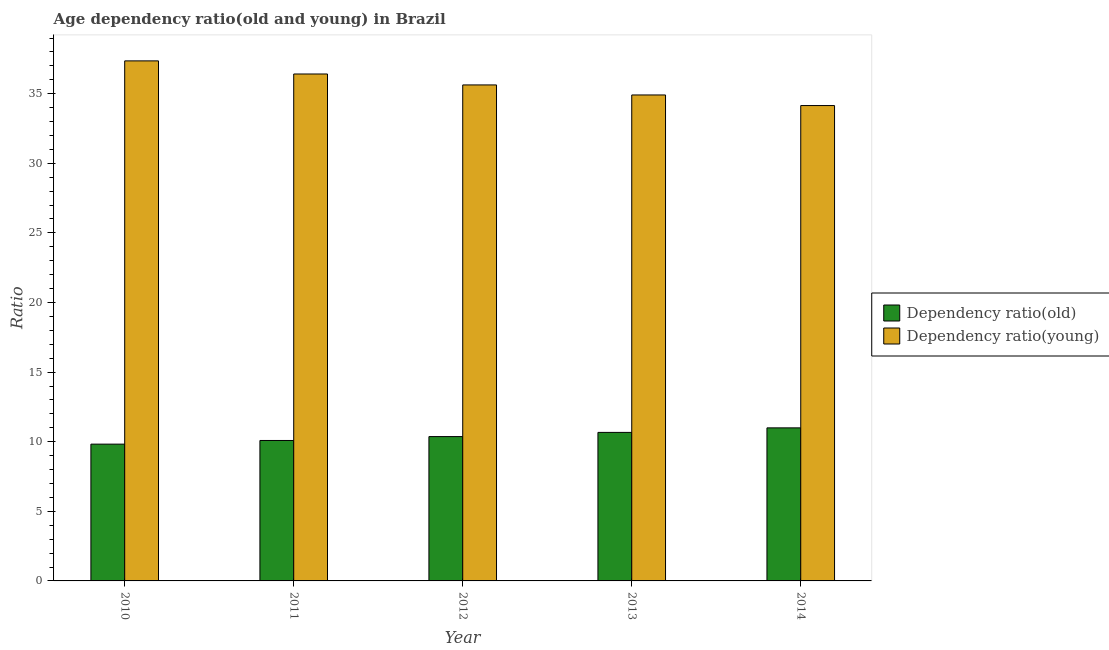How many different coloured bars are there?
Your response must be concise. 2. Are the number of bars per tick equal to the number of legend labels?
Make the answer very short. Yes. Are the number of bars on each tick of the X-axis equal?
Ensure brevity in your answer.  Yes. What is the age dependency ratio(old) in 2013?
Give a very brief answer. 10.67. Across all years, what is the maximum age dependency ratio(old)?
Offer a very short reply. 11. Across all years, what is the minimum age dependency ratio(young)?
Provide a short and direct response. 34.15. What is the total age dependency ratio(old) in the graph?
Offer a terse response. 51.95. What is the difference between the age dependency ratio(old) in 2010 and that in 2011?
Provide a succinct answer. -0.26. What is the difference between the age dependency ratio(old) in 2012 and the age dependency ratio(young) in 2010?
Offer a terse response. 0.54. What is the average age dependency ratio(old) per year?
Your answer should be very brief. 10.39. What is the ratio of the age dependency ratio(young) in 2010 to that in 2013?
Ensure brevity in your answer.  1.07. What is the difference between the highest and the second highest age dependency ratio(young)?
Give a very brief answer. 0.94. What is the difference between the highest and the lowest age dependency ratio(young)?
Your answer should be very brief. 3.21. In how many years, is the age dependency ratio(young) greater than the average age dependency ratio(young) taken over all years?
Your answer should be compact. 2. What does the 2nd bar from the left in 2014 represents?
Ensure brevity in your answer.  Dependency ratio(young). What does the 2nd bar from the right in 2012 represents?
Give a very brief answer. Dependency ratio(old). Are all the bars in the graph horizontal?
Make the answer very short. No. How many years are there in the graph?
Give a very brief answer. 5. Are the values on the major ticks of Y-axis written in scientific E-notation?
Your answer should be very brief. No. Does the graph contain any zero values?
Your answer should be compact. No. Where does the legend appear in the graph?
Provide a succinct answer. Center right. What is the title of the graph?
Make the answer very short. Age dependency ratio(old and young) in Brazil. What is the label or title of the Y-axis?
Offer a terse response. Ratio. What is the Ratio in Dependency ratio(old) in 2010?
Keep it short and to the point. 9.83. What is the Ratio in Dependency ratio(young) in 2010?
Offer a terse response. 37.36. What is the Ratio of Dependency ratio(old) in 2011?
Offer a very short reply. 10.09. What is the Ratio in Dependency ratio(young) in 2011?
Make the answer very short. 36.42. What is the Ratio in Dependency ratio(old) in 2012?
Ensure brevity in your answer.  10.37. What is the Ratio of Dependency ratio(young) in 2012?
Your answer should be very brief. 35.63. What is the Ratio of Dependency ratio(old) in 2013?
Keep it short and to the point. 10.67. What is the Ratio in Dependency ratio(young) in 2013?
Your response must be concise. 34.91. What is the Ratio in Dependency ratio(old) in 2014?
Give a very brief answer. 11. What is the Ratio of Dependency ratio(young) in 2014?
Give a very brief answer. 34.15. Across all years, what is the maximum Ratio of Dependency ratio(old)?
Ensure brevity in your answer.  11. Across all years, what is the maximum Ratio in Dependency ratio(young)?
Provide a succinct answer. 37.36. Across all years, what is the minimum Ratio in Dependency ratio(old)?
Your answer should be compact. 9.83. Across all years, what is the minimum Ratio in Dependency ratio(young)?
Offer a terse response. 34.15. What is the total Ratio of Dependency ratio(old) in the graph?
Provide a short and direct response. 51.95. What is the total Ratio in Dependency ratio(young) in the graph?
Provide a short and direct response. 178.46. What is the difference between the Ratio of Dependency ratio(old) in 2010 and that in 2011?
Your response must be concise. -0.26. What is the difference between the Ratio in Dependency ratio(young) in 2010 and that in 2011?
Provide a succinct answer. 0.94. What is the difference between the Ratio in Dependency ratio(old) in 2010 and that in 2012?
Offer a terse response. -0.54. What is the difference between the Ratio in Dependency ratio(young) in 2010 and that in 2012?
Offer a very short reply. 1.73. What is the difference between the Ratio in Dependency ratio(old) in 2010 and that in 2013?
Ensure brevity in your answer.  -0.84. What is the difference between the Ratio in Dependency ratio(young) in 2010 and that in 2013?
Your response must be concise. 2.45. What is the difference between the Ratio of Dependency ratio(old) in 2010 and that in 2014?
Give a very brief answer. -1.17. What is the difference between the Ratio of Dependency ratio(young) in 2010 and that in 2014?
Keep it short and to the point. 3.21. What is the difference between the Ratio of Dependency ratio(old) in 2011 and that in 2012?
Provide a succinct answer. -0.28. What is the difference between the Ratio of Dependency ratio(young) in 2011 and that in 2012?
Provide a succinct answer. 0.79. What is the difference between the Ratio in Dependency ratio(old) in 2011 and that in 2013?
Your answer should be very brief. -0.58. What is the difference between the Ratio of Dependency ratio(young) in 2011 and that in 2013?
Keep it short and to the point. 1.51. What is the difference between the Ratio in Dependency ratio(old) in 2011 and that in 2014?
Offer a terse response. -0.91. What is the difference between the Ratio in Dependency ratio(young) in 2011 and that in 2014?
Your answer should be compact. 2.27. What is the difference between the Ratio of Dependency ratio(old) in 2012 and that in 2013?
Offer a terse response. -0.3. What is the difference between the Ratio in Dependency ratio(young) in 2012 and that in 2013?
Give a very brief answer. 0.72. What is the difference between the Ratio of Dependency ratio(old) in 2012 and that in 2014?
Provide a succinct answer. -0.63. What is the difference between the Ratio of Dependency ratio(young) in 2012 and that in 2014?
Make the answer very short. 1.48. What is the difference between the Ratio in Dependency ratio(old) in 2013 and that in 2014?
Your response must be concise. -0.33. What is the difference between the Ratio in Dependency ratio(young) in 2013 and that in 2014?
Make the answer very short. 0.76. What is the difference between the Ratio of Dependency ratio(old) in 2010 and the Ratio of Dependency ratio(young) in 2011?
Make the answer very short. -26.59. What is the difference between the Ratio in Dependency ratio(old) in 2010 and the Ratio in Dependency ratio(young) in 2012?
Offer a terse response. -25.8. What is the difference between the Ratio of Dependency ratio(old) in 2010 and the Ratio of Dependency ratio(young) in 2013?
Offer a terse response. -25.08. What is the difference between the Ratio of Dependency ratio(old) in 2010 and the Ratio of Dependency ratio(young) in 2014?
Your answer should be very brief. -24.32. What is the difference between the Ratio of Dependency ratio(old) in 2011 and the Ratio of Dependency ratio(young) in 2012?
Offer a terse response. -25.54. What is the difference between the Ratio of Dependency ratio(old) in 2011 and the Ratio of Dependency ratio(young) in 2013?
Keep it short and to the point. -24.82. What is the difference between the Ratio of Dependency ratio(old) in 2011 and the Ratio of Dependency ratio(young) in 2014?
Keep it short and to the point. -24.06. What is the difference between the Ratio in Dependency ratio(old) in 2012 and the Ratio in Dependency ratio(young) in 2013?
Your answer should be compact. -24.54. What is the difference between the Ratio of Dependency ratio(old) in 2012 and the Ratio of Dependency ratio(young) in 2014?
Ensure brevity in your answer.  -23.78. What is the difference between the Ratio of Dependency ratio(old) in 2013 and the Ratio of Dependency ratio(young) in 2014?
Offer a very short reply. -23.48. What is the average Ratio in Dependency ratio(old) per year?
Provide a succinct answer. 10.39. What is the average Ratio of Dependency ratio(young) per year?
Offer a terse response. 35.69. In the year 2010, what is the difference between the Ratio in Dependency ratio(old) and Ratio in Dependency ratio(young)?
Make the answer very short. -27.53. In the year 2011, what is the difference between the Ratio of Dependency ratio(old) and Ratio of Dependency ratio(young)?
Provide a succinct answer. -26.33. In the year 2012, what is the difference between the Ratio in Dependency ratio(old) and Ratio in Dependency ratio(young)?
Provide a short and direct response. -25.26. In the year 2013, what is the difference between the Ratio of Dependency ratio(old) and Ratio of Dependency ratio(young)?
Give a very brief answer. -24.24. In the year 2014, what is the difference between the Ratio in Dependency ratio(old) and Ratio in Dependency ratio(young)?
Your response must be concise. -23.15. What is the ratio of the Ratio in Dependency ratio(young) in 2010 to that in 2011?
Provide a succinct answer. 1.03. What is the ratio of the Ratio of Dependency ratio(old) in 2010 to that in 2012?
Your answer should be very brief. 0.95. What is the ratio of the Ratio of Dependency ratio(young) in 2010 to that in 2012?
Keep it short and to the point. 1.05. What is the ratio of the Ratio in Dependency ratio(old) in 2010 to that in 2013?
Your answer should be very brief. 0.92. What is the ratio of the Ratio in Dependency ratio(young) in 2010 to that in 2013?
Offer a terse response. 1.07. What is the ratio of the Ratio of Dependency ratio(old) in 2010 to that in 2014?
Offer a very short reply. 0.89. What is the ratio of the Ratio in Dependency ratio(young) in 2010 to that in 2014?
Your answer should be compact. 1.09. What is the ratio of the Ratio in Dependency ratio(young) in 2011 to that in 2012?
Your response must be concise. 1.02. What is the ratio of the Ratio in Dependency ratio(old) in 2011 to that in 2013?
Your answer should be very brief. 0.95. What is the ratio of the Ratio in Dependency ratio(young) in 2011 to that in 2013?
Your response must be concise. 1.04. What is the ratio of the Ratio in Dependency ratio(old) in 2011 to that in 2014?
Keep it short and to the point. 0.92. What is the ratio of the Ratio of Dependency ratio(young) in 2011 to that in 2014?
Provide a succinct answer. 1.07. What is the ratio of the Ratio of Dependency ratio(old) in 2012 to that in 2013?
Provide a succinct answer. 0.97. What is the ratio of the Ratio of Dependency ratio(young) in 2012 to that in 2013?
Your response must be concise. 1.02. What is the ratio of the Ratio of Dependency ratio(old) in 2012 to that in 2014?
Ensure brevity in your answer.  0.94. What is the ratio of the Ratio of Dependency ratio(young) in 2012 to that in 2014?
Your response must be concise. 1.04. What is the ratio of the Ratio of Dependency ratio(old) in 2013 to that in 2014?
Your answer should be compact. 0.97. What is the ratio of the Ratio of Dependency ratio(young) in 2013 to that in 2014?
Keep it short and to the point. 1.02. What is the difference between the highest and the second highest Ratio of Dependency ratio(old)?
Offer a terse response. 0.33. What is the difference between the highest and the second highest Ratio in Dependency ratio(young)?
Keep it short and to the point. 0.94. What is the difference between the highest and the lowest Ratio in Dependency ratio(old)?
Your answer should be compact. 1.17. What is the difference between the highest and the lowest Ratio of Dependency ratio(young)?
Offer a very short reply. 3.21. 